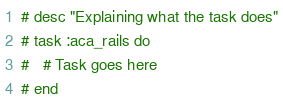Convert code to text. <code><loc_0><loc_0><loc_500><loc_500><_Ruby_># desc "Explaining what the task does"
# task :aca_rails do
#   # Task goes here
# end
</code> 